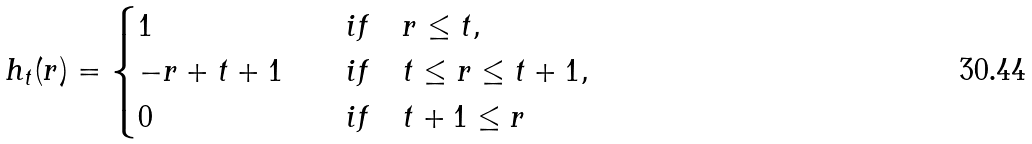<formula> <loc_0><loc_0><loc_500><loc_500>h _ { t } ( r ) = \begin{cases} 1 \quad & i f \quad r \leq t , \\ - r + t + 1 \quad & i f \quad t \leq r \leq t + 1 , \\ 0 \quad & i f \quad t + 1 \leq r \end{cases}</formula> 